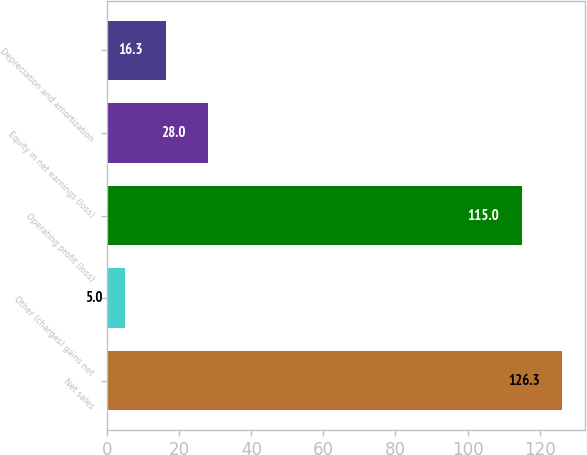Convert chart to OTSL. <chart><loc_0><loc_0><loc_500><loc_500><bar_chart><fcel>Net sales<fcel>Other (charges) gains net<fcel>Operating profit (loss)<fcel>Equity in net earnings (loss)<fcel>Depreciation and amortization<nl><fcel>126.3<fcel>5<fcel>115<fcel>28<fcel>16.3<nl></chart> 